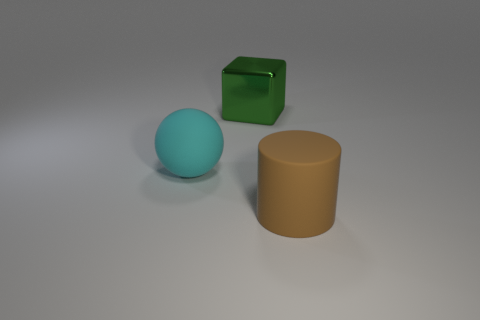Is there anything else that is made of the same material as the green block?
Provide a short and direct response. No. How many things are cyan objects or rubber objects that are in front of the large ball?
Your answer should be compact. 2. Is the number of big metal cubes that are behind the large metal block the same as the number of big shiny cubes?
Provide a short and direct response. No. The big thing that is made of the same material as the brown cylinder is what shape?
Provide a short and direct response. Sphere. What number of rubber objects are either large brown things or large gray cubes?
Give a very brief answer. 1. There is a large brown rubber object in front of the metallic object; how many big cubes are left of it?
Offer a terse response. 1. How many other large blocks are made of the same material as the green block?
Provide a short and direct response. 0. How many large objects are either cyan objects or brown matte balls?
Ensure brevity in your answer.  1. There is a thing that is both in front of the large green object and to the left of the rubber cylinder; what shape is it?
Your response must be concise. Sphere. Does the ball have the same material as the big green object?
Provide a short and direct response. No. 